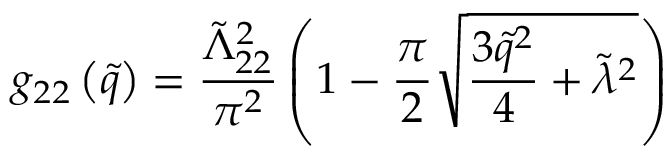<formula> <loc_0><loc_0><loc_500><loc_500>g _ { 2 2 } \left ( \tilde { q } \right ) = \frac { \tilde { \Lambda } _ { 2 2 } ^ { 2 } } { \pi ^ { 2 } } \left ( 1 - \frac { \pi } { 2 } \sqrt { \frac { 3 \tilde { q } ^ { 2 } } { 4 } + \tilde { \lambda } ^ { 2 } } \right )</formula> 